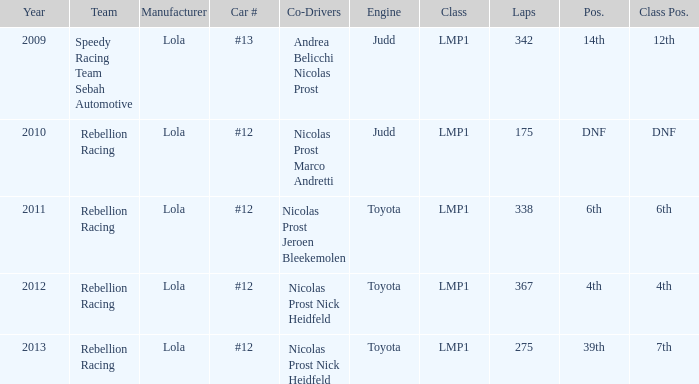What was the class position of the team that was in the 4th position? 4th. 